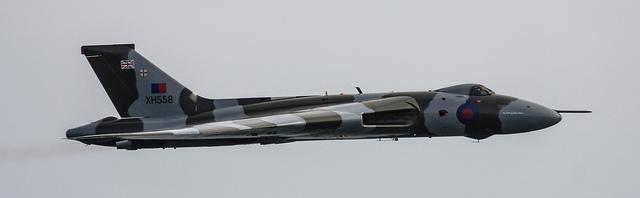Can you see plants?
Concise answer only. No. What side of the plane is visible?
Give a very brief answer. Right. What country's flag is on the tail of the plane?
Answer briefly. Usa. What flag is on the tail of the aircraft?
Write a very short answer. Yes. What color is the plain?
Keep it brief. Gray, brown. Is the plane going to land?
Keep it brief. No. Is this a passenger aircraft?
Write a very short answer. No. 